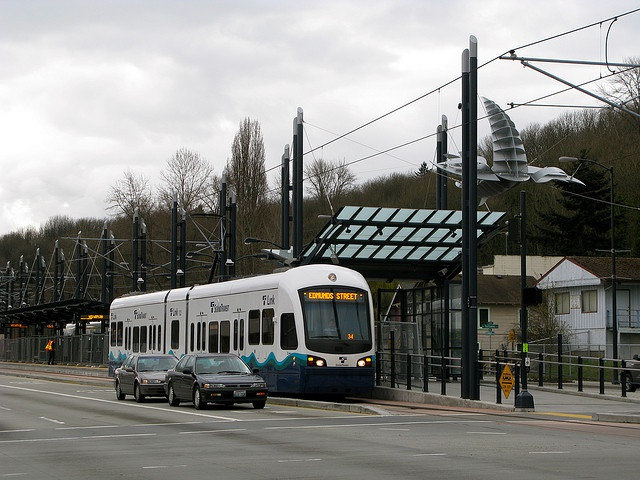Describe the objects in this image and their specific colors. I can see bus in lavender, black, darkgray, lightgray, and gray tones, car in lavender, black, gray, and darkgray tones, car in lavender, black, gray, and darkgray tones, car in lavender, black, gray, and darkgray tones, and traffic light in black, gray, darkgray, and lavender tones in this image. 